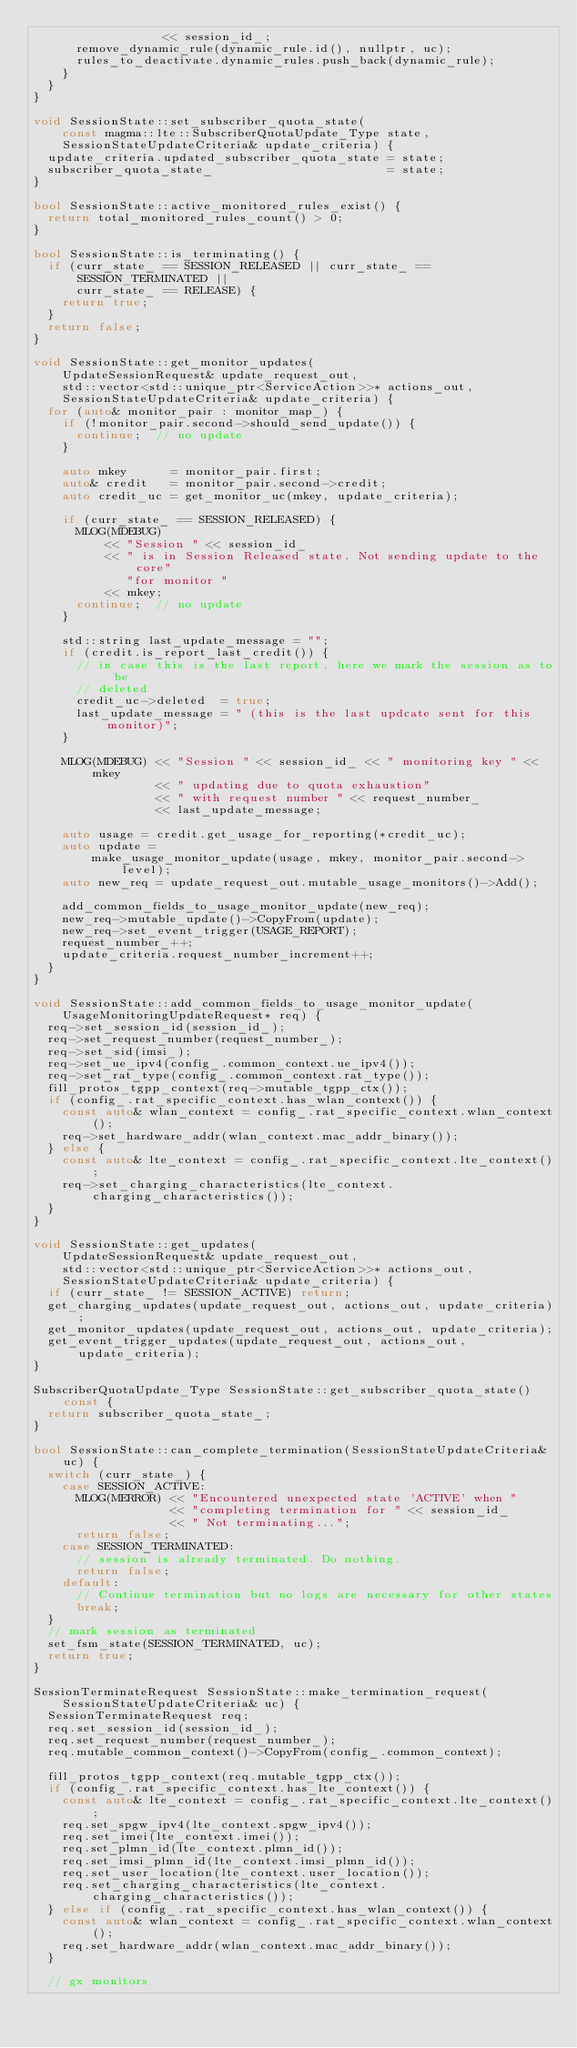<code> <loc_0><loc_0><loc_500><loc_500><_C++_>                  << session_id_;
      remove_dynamic_rule(dynamic_rule.id(), nullptr, uc);
      rules_to_deactivate.dynamic_rules.push_back(dynamic_rule);
    }
  }
}

void SessionState::set_subscriber_quota_state(
    const magma::lte::SubscriberQuotaUpdate_Type state,
    SessionStateUpdateCriteria& update_criteria) {
  update_criteria.updated_subscriber_quota_state = state;
  subscriber_quota_state_                        = state;
}

bool SessionState::active_monitored_rules_exist() {
  return total_monitored_rules_count() > 0;
}

bool SessionState::is_terminating() {
  if (curr_state_ == SESSION_RELEASED || curr_state_ == SESSION_TERMINATED ||
      curr_state_ == RELEASE) {
    return true;
  }
  return false;
}

void SessionState::get_monitor_updates(
    UpdateSessionRequest& update_request_out,
    std::vector<std::unique_ptr<ServiceAction>>* actions_out,
    SessionStateUpdateCriteria& update_criteria) {
  for (auto& monitor_pair : monitor_map_) {
    if (!monitor_pair.second->should_send_update()) {
      continue;  // no update
    }

    auto mkey      = monitor_pair.first;
    auto& credit   = monitor_pair.second->credit;
    auto credit_uc = get_monitor_uc(mkey, update_criteria);

    if (curr_state_ == SESSION_RELEASED) {
      MLOG(MDEBUG)
          << "Session " << session_id_
          << " is in Session Released state. Not sending update to the core"
             "for monitor "
          << mkey;
      continue;  // no update
    }

    std::string last_update_message = "";
    if (credit.is_report_last_credit()) {
      // in case this is the last report, here we mark the session as to be
      // deleted
      credit_uc->deleted  = true;
      last_update_message = " (this is the last updcate sent for this monitor)";
    }

    MLOG(MDEBUG) << "Session " << session_id_ << " monitoring key " << mkey
                 << " updating due to quota exhaustion"
                 << " with request number " << request_number_
                 << last_update_message;

    auto usage = credit.get_usage_for_reporting(*credit_uc);
    auto update =
        make_usage_monitor_update(usage, mkey, monitor_pair.second->level);
    auto new_req = update_request_out.mutable_usage_monitors()->Add();

    add_common_fields_to_usage_monitor_update(new_req);
    new_req->mutable_update()->CopyFrom(update);
    new_req->set_event_trigger(USAGE_REPORT);
    request_number_++;
    update_criteria.request_number_increment++;
  }
}

void SessionState::add_common_fields_to_usage_monitor_update(
    UsageMonitoringUpdateRequest* req) {
  req->set_session_id(session_id_);
  req->set_request_number(request_number_);
  req->set_sid(imsi_);
  req->set_ue_ipv4(config_.common_context.ue_ipv4());
  req->set_rat_type(config_.common_context.rat_type());
  fill_protos_tgpp_context(req->mutable_tgpp_ctx());
  if (config_.rat_specific_context.has_wlan_context()) {
    const auto& wlan_context = config_.rat_specific_context.wlan_context();
    req->set_hardware_addr(wlan_context.mac_addr_binary());
  } else {
    const auto& lte_context = config_.rat_specific_context.lte_context();
    req->set_charging_characteristics(lte_context.charging_characteristics());
  }
}

void SessionState::get_updates(
    UpdateSessionRequest& update_request_out,
    std::vector<std::unique_ptr<ServiceAction>>* actions_out,
    SessionStateUpdateCriteria& update_criteria) {
  if (curr_state_ != SESSION_ACTIVE) return;
  get_charging_updates(update_request_out, actions_out, update_criteria);
  get_monitor_updates(update_request_out, actions_out, update_criteria);
  get_event_trigger_updates(update_request_out, actions_out, update_criteria);
}

SubscriberQuotaUpdate_Type SessionState::get_subscriber_quota_state() const {
  return subscriber_quota_state_;
}

bool SessionState::can_complete_termination(SessionStateUpdateCriteria& uc) {
  switch (curr_state_) {
    case SESSION_ACTIVE:
      MLOG(MERROR) << "Encountered unexpected state 'ACTIVE' when "
                   << "completing termination for " << session_id_
                   << " Not terminating...";
      return false;
    case SESSION_TERMINATED:
      // session is already terminated. Do nothing.
      return false;
    default:
      // Continue termination but no logs are necessary for other states
      break;
  }
  // mark session as terminated
  set_fsm_state(SESSION_TERMINATED, uc);
  return true;
}

SessionTerminateRequest SessionState::make_termination_request(
    SessionStateUpdateCriteria& uc) {
  SessionTerminateRequest req;
  req.set_session_id(session_id_);
  req.set_request_number(request_number_);
  req.mutable_common_context()->CopyFrom(config_.common_context);

  fill_protos_tgpp_context(req.mutable_tgpp_ctx());
  if (config_.rat_specific_context.has_lte_context()) {
    const auto& lte_context = config_.rat_specific_context.lte_context();
    req.set_spgw_ipv4(lte_context.spgw_ipv4());
    req.set_imei(lte_context.imei());
    req.set_plmn_id(lte_context.plmn_id());
    req.set_imsi_plmn_id(lte_context.imsi_plmn_id());
    req.set_user_location(lte_context.user_location());
    req.set_charging_characteristics(lte_context.charging_characteristics());
  } else if (config_.rat_specific_context.has_wlan_context()) {
    const auto& wlan_context = config_.rat_specific_context.wlan_context();
    req.set_hardware_addr(wlan_context.mac_addr_binary());
  }

  // gx monitors</code> 